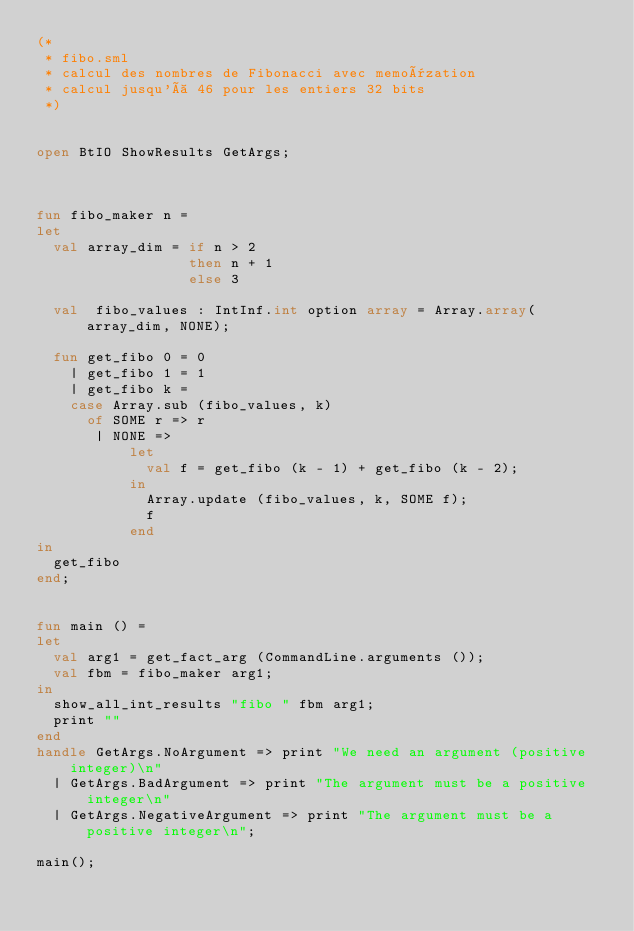Convert code to text. <code><loc_0><loc_0><loc_500><loc_500><_SML_>(*
 * fibo.sml
 * calcul des nombres de Fibonacci avec memoïzation
 * calcul jusqu'à 46 pour les entiers 32 bits
 *)


open BtIO ShowResults GetArgs;



fun fibo_maker n =
let
  val array_dim = if n > 2
                  then n + 1
                  else 3

  val  fibo_values : IntInf.int option array = Array.array(array_dim, NONE);

  fun get_fibo 0 = 0
    | get_fibo 1 = 1
    | get_fibo k =
    case Array.sub (fibo_values, k)
      of SOME r => r
       | NONE =>
           let
             val f = get_fibo (k - 1) + get_fibo (k - 2);
           in
             Array.update (fibo_values, k, SOME f);
             f
           end
in
  get_fibo
end;


fun main () =
let
  val arg1 = get_fact_arg (CommandLine.arguments ());
  val fbm = fibo_maker arg1;
in
  show_all_int_results "fibo " fbm arg1;
  print ""
end
handle GetArgs.NoArgument => print "We need an argument (positive integer)\n"
  | GetArgs.BadArgument => print "The argument must be a positive integer\n"
  | GetArgs.NegativeArgument => print "The argument must be a positive integer\n";

main();
</code> 